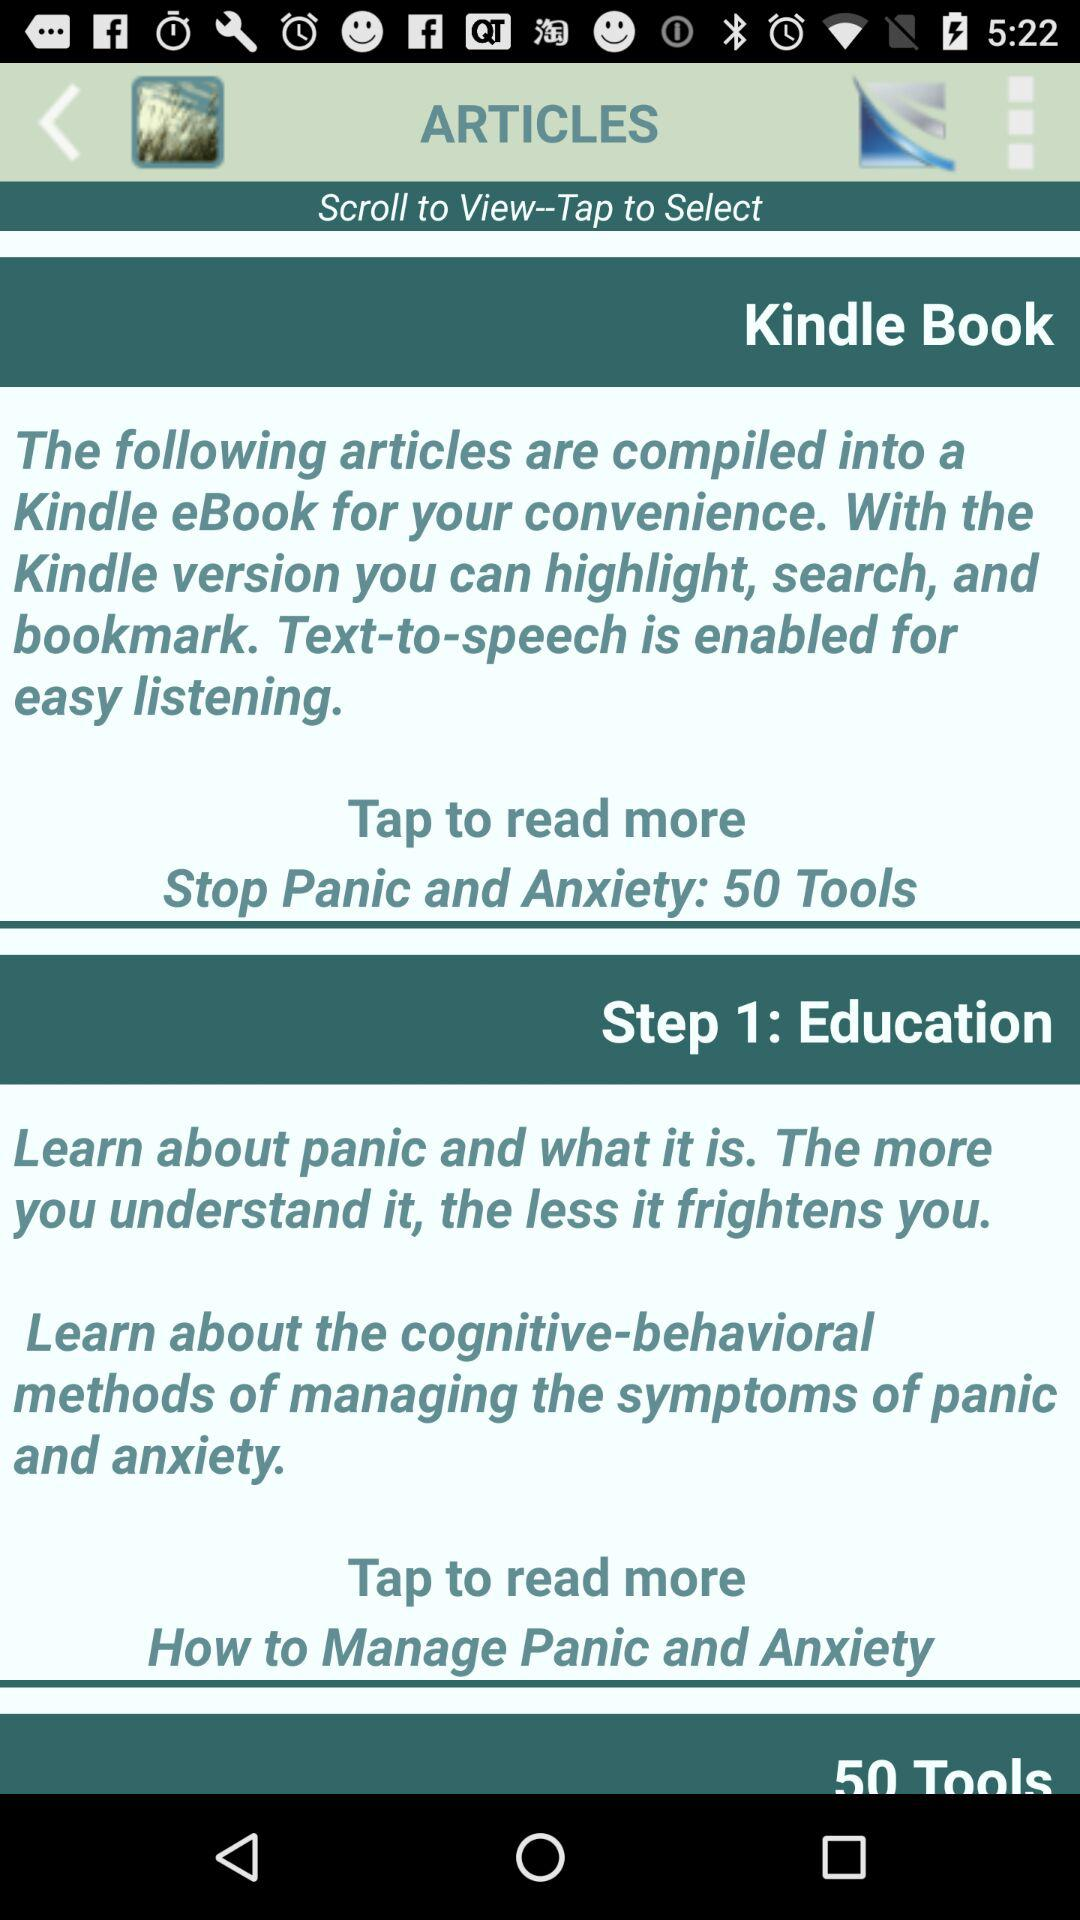Which feature is enabled for easy listening? The feature that is enabled for easy listening is "Text-to-speech". 